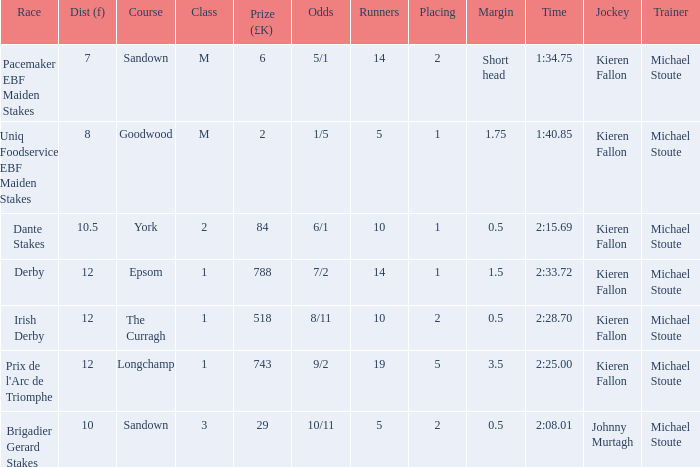Would you be able to parse every entry in this table? {'header': ['Race', 'Dist (f)', 'Course', 'Class', 'Prize (£K)', 'Odds', 'Runners', 'Placing', 'Margin', 'Time', 'Jockey', 'Trainer'], 'rows': [['Pacemaker EBF Maiden Stakes', '7', 'Sandown', 'M', '6', '5/1', '14', '2', 'Short head', '1:34.75', 'Kieren Fallon', 'Michael Stoute'], ['Uniq Foodservice EBF Maiden Stakes', '8', 'Goodwood', 'M', '2', '1/5', '5', '1', '1.75', '1:40.85', 'Kieren Fallon', 'Michael Stoute'], ['Dante Stakes', '10.5', 'York', '2', '84', '6/1', '10', '1', '0.5', '2:15.69', 'Kieren Fallon', 'Michael Stoute'], ['Derby', '12', 'Epsom', '1', '788', '7/2', '14', '1', '1.5', '2:33.72', 'Kieren Fallon', 'Michael Stoute'], ['Irish Derby', '12', 'The Curragh', '1', '518', '8/11', '10', '2', '0.5', '2:28.70', 'Kieren Fallon', 'Michael Stoute'], ["Prix de l'Arc de Triomphe", '12', 'Longchamp', '1', '743', '9/2', '19', '5', '3.5', '2:25.00', 'Kieren Fallon', 'Michael Stoute'], ['Brigadier Gerard Stakes', '10', 'Sandown', '3', '29', '10/11', '5', '2', '0.5', '2:08.01', 'Johnny Murtagh', 'Michael Stoute']]} Identify the fewest participants with a distance of 1 10.0. 